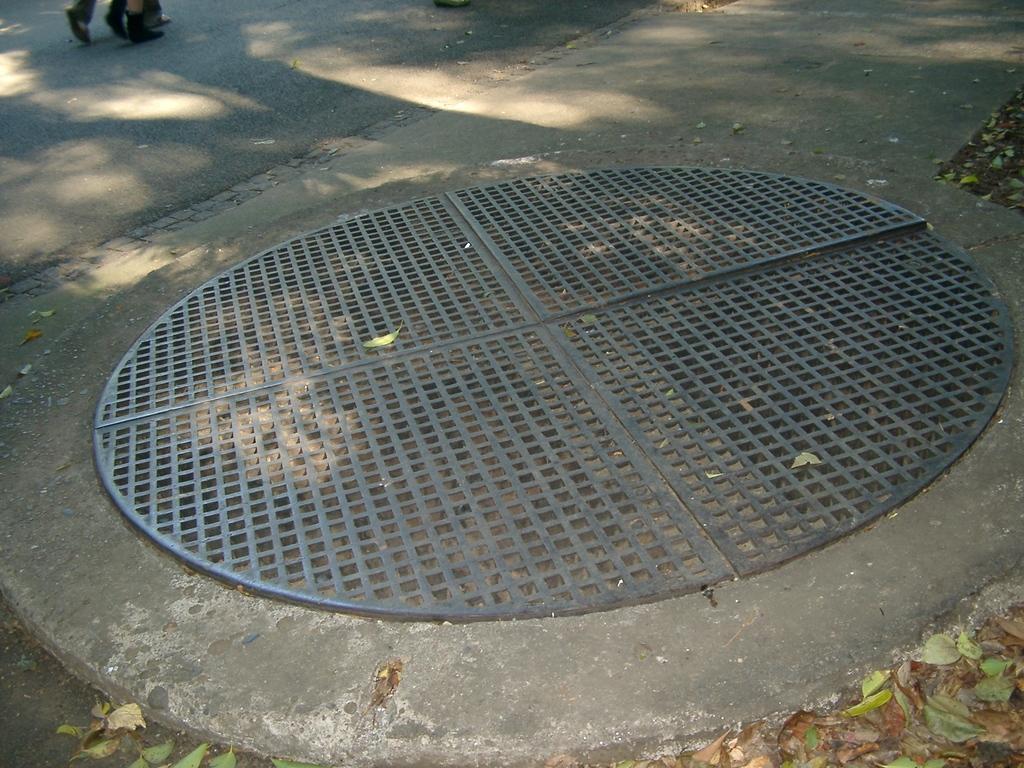Describe this image in one or two sentences. In this image I can see the road. I can see the person's legs on the road. To the side of the road I can see the manhole lid and the leaves. 